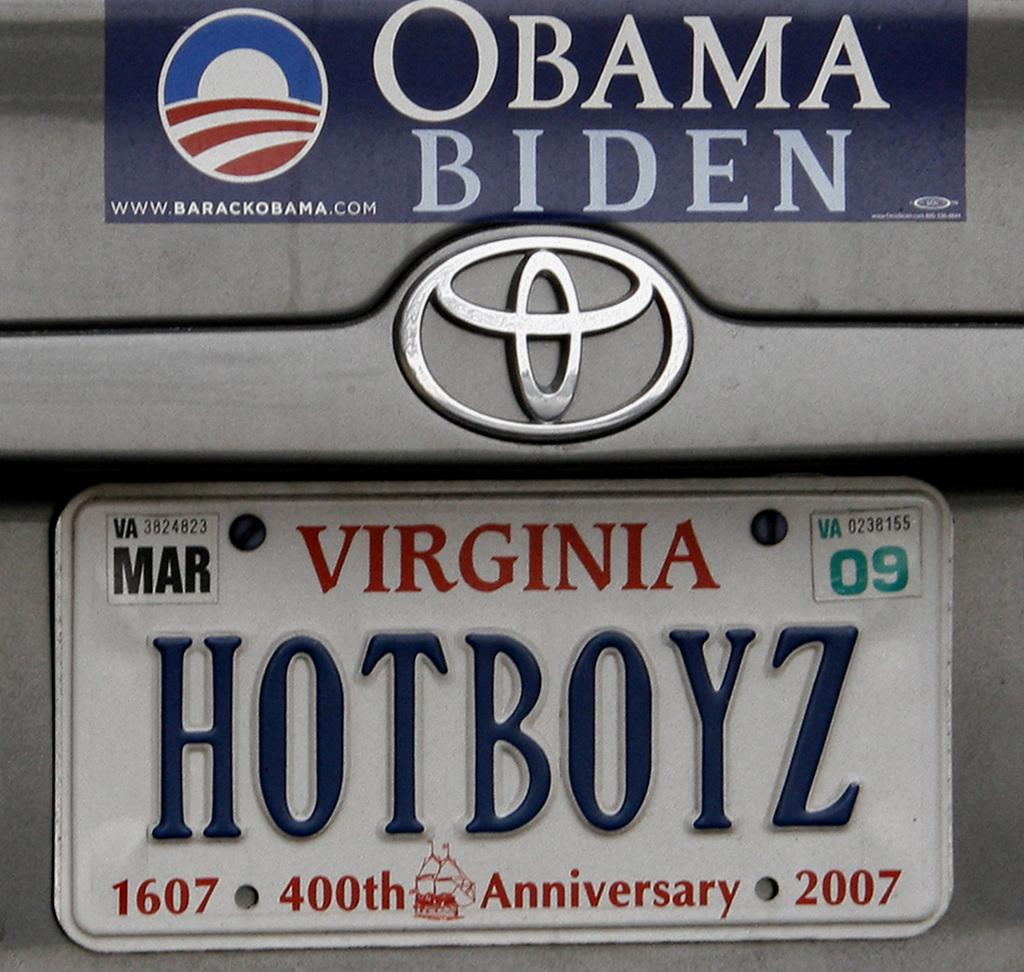<image>
Give a short and clear explanation of the subsequent image. A silver car from Virginia has an Obama sticker on it and the license plate "HOTBOYZ". 